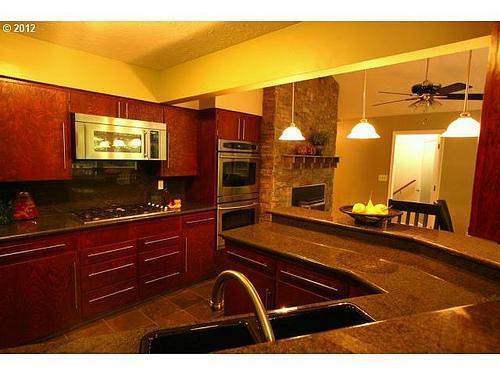How many lights are on?
Give a very brief answer. 3. 